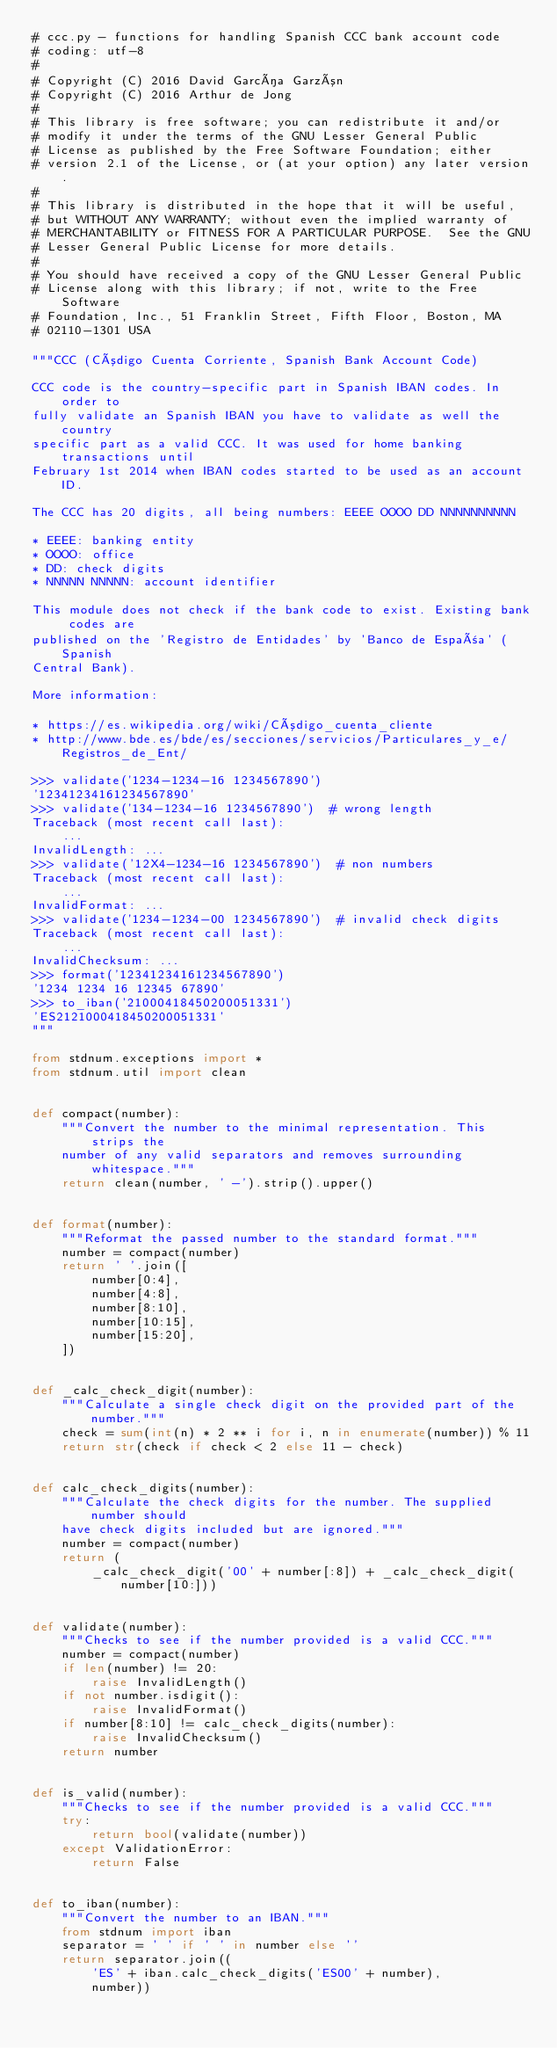<code> <loc_0><loc_0><loc_500><loc_500><_Python_># ccc.py - functions for handling Spanish CCC bank account code
# coding: utf-8
#
# Copyright (C) 2016 David García Garzón
# Copyright (C) 2016 Arthur de Jong
#
# This library is free software; you can redistribute it and/or
# modify it under the terms of the GNU Lesser General Public
# License as published by the Free Software Foundation; either
# version 2.1 of the License, or (at your option) any later version.
#
# This library is distributed in the hope that it will be useful,
# but WITHOUT ANY WARRANTY; without even the implied warranty of
# MERCHANTABILITY or FITNESS FOR A PARTICULAR PURPOSE.  See the GNU
# Lesser General Public License for more details.
#
# You should have received a copy of the GNU Lesser General Public
# License along with this library; if not, write to the Free Software
# Foundation, Inc., 51 Franklin Street, Fifth Floor, Boston, MA
# 02110-1301 USA

"""CCC (Código Cuenta Corriente, Spanish Bank Account Code)

CCC code is the country-specific part in Spanish IBAN codes. In order to
fully validate an Spanish IBAN you have to validate as well the country
specific part as a valid CCC. It was used for home banking transactions until
February 1st 2014 when IBAN codes started to be used as an account ID.

The CCC has 20 digits, all being numbers: EEEE OOOO DD NNNNNNNNNN

* EEEE: banking entity
* OOOO: office
* DD: check digits
* NNNNN NNNNN: account identifier

This module does not check if the bank code to exist. Existing bank codes are
published on the 'Registro de Entidades' by 'Banco de España' (Spanish
Central Bank).

More information:

* https://es.wikipedia.org/wiki/Código_cuenta_cliente
* http://www.bde.es/bde/es/secciones/servicios/Particulares_y_e/Registros_de_Ent/

>>> validate('1234-1234-16 1234567890')
'12341234161234567890'
>>> validate('134-1234-16 1234567890')  # wrong length
Traceback (most recent call last):
    ...
InvalidLength: ...
>>> validate('12X4-1234-16 1234567890')  # non numbers
Traceback (most recent call last):
    ...
InvalidFormat: ...
>>> validate('1234-1234-00 1234567890')  # invalid check digits
Traceback (most recent call last):
    ...
InvalidChecksum: ...
>>> format('12341234161234567890')
'1234 1234 16 12345 67890'
>>> to_iban('21000418450200051331')
'ES2121000418450200051331'
"""

from stdnum.exceptions import *
from stdnum.util import clean


def compact(number):
    """Convert the number to the minimal representation. This strips the
    number of any valid separators and removes surrounding whitespace."""
    return clean(number, ' -').strip().upper()


def format(number):
    """Reformat the passed number to the standard format."""
    number = compact(number)
    return ' '.join([
        number[0:4],
        number[4:8],
        number[8:10],
        number[10:15],
        number[15:20],
    ])


def _calc_check_digit(number):
    """Calculate a single check digit on the provided part of the number."""
    check = sum(int(n) * 2 ** i for i, n in enumerate(number)) % 11
    return str(check if check < 2 else 11 - check)


def calc_check_digits(number):
    """Calculate the check digits for the number. The supplied number should
    have check digits included but are ignored."""
    number = compact(number)
    return (
        _calc_check_digit('00' + number[:8]) + _calc_check_digit(number[10:]))


def validate(number):
    """Checks to see if the number provided is a valid CCC."""
    number = compact(number)
    if len(number) != 20:
        raise InvalidLength()
    if not number.isdigit():
        raise InvalidFormat()
    if number[8:10] != calc_check_digits(number):
        raise InvalidChecksum()
    return number


def is_valid(number):
    """Checks to see if the number provided is a valid CCC."""
    try:
        return bool(validate(number))
    except ValidationError:
        return False


def to_iban(number):
    """Convert the number to an IBAN."""
    from stdnum import iban
    separator = ' ' if ' ' in number else ''
    return separator.join((
        'ES' + iban.calc_check_digits('ES00' + number),
        number))
</code> 